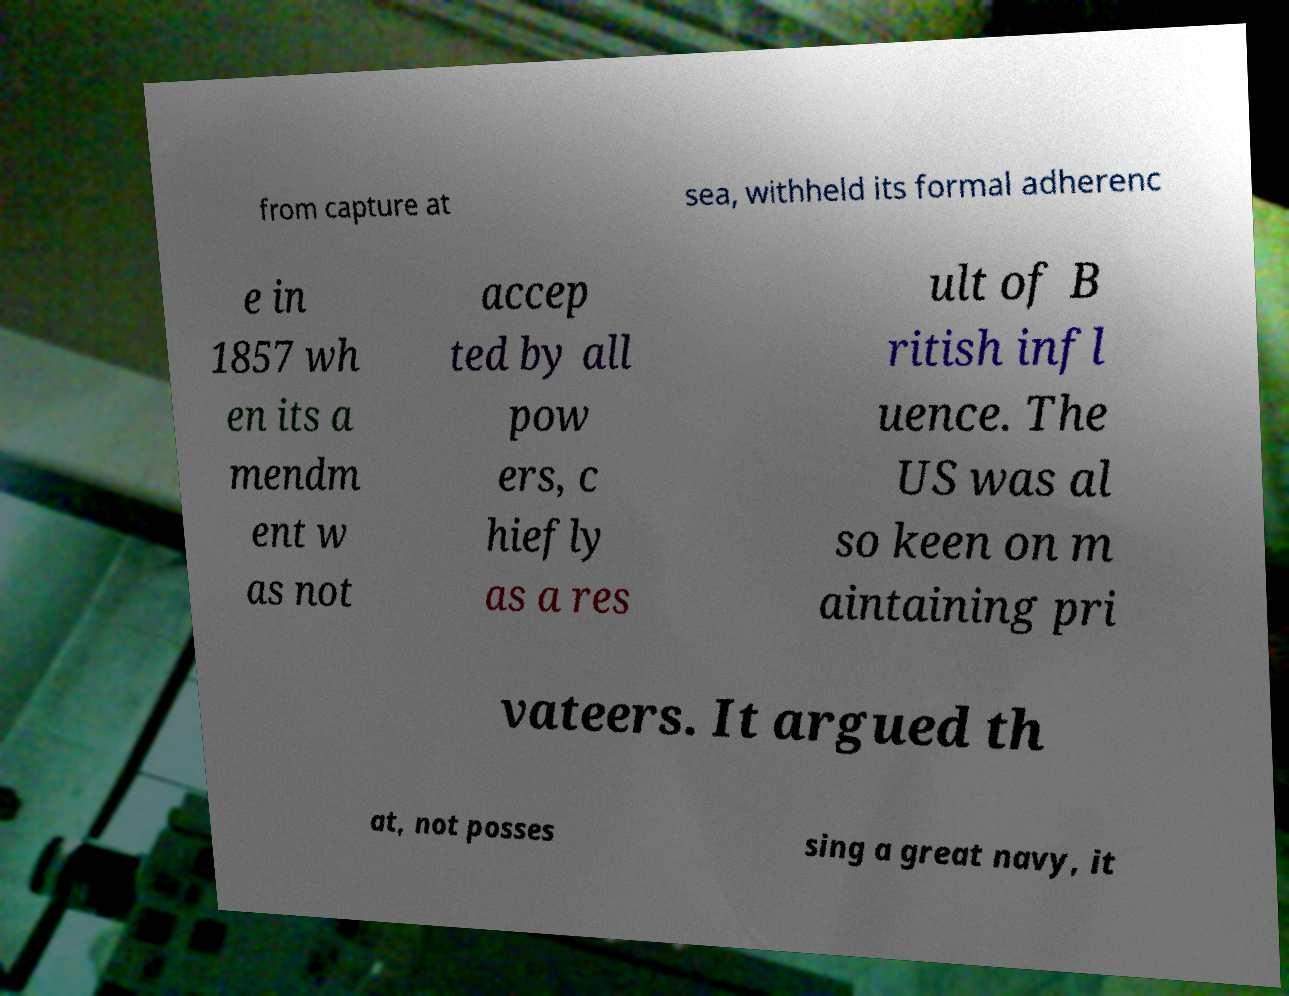Please identify and transcribe the text found in this image. from capture at sea, withheld its formal adherenc e in 1857 wh en its a mendm ent w as not accep ted by all pow ers, c hiefly as a res ult of B ritish infl uence. The US was al so keen on m aintaining pri vateers. It argued th at, not posses sing a great navy, it 